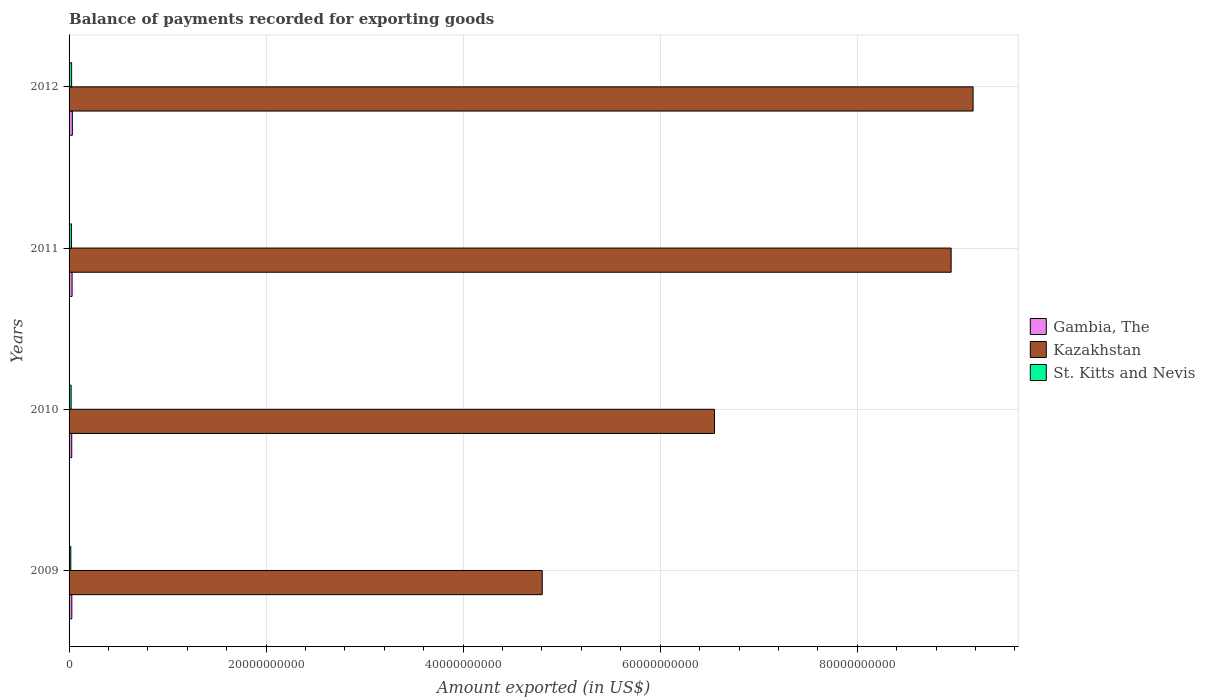How many groups of bars are there?
Offer a very short reply. 4. Are the number of bars on each tick of the Y-axis equal?
Your answer should be compact. Yes. What is the label of the 3rd group of bars from the top?
Ensure brevity in your answer.  2010. What is the amount exported in Gambia, The in 2012?
Your answer should be compact. 3.34e+08. Across all years, what is the maximum amount exported in St. Kitts and Nevis?
Your answer should be very brief. 2.57e+08. Across all years, what is the minimum amount exported in Kazakhstan?
Your answer should be compact. 4.80e+1. In which year was the amount exported in Gambia, The maximum?
Make the answer very short. 2012. What is the total amount exported in Gambia, The in the graph?
Provide a succinct answer. 1.19e+09. What is the difference between the amount exported in Gambia, The in 2011 and that in 2012?
Offer a very short reply. -2.81e+07. What is the difference between the amount exported in Gambia, The in 2009 and the amount exported in Kazakhstan in 2011?
Give a very brief answer. -8.93e+1. What is the average amount exported in Kazakhstan per year?
Keep it short and to the point. 7.37e+1. In the year 2009, what is the difference between the amount exported in Kazakhstan and amount exported in Gambia, The?
Offer a terse response. 4.77e+1. What is the ratio of the amount exported in Gambia, The in 2010 to that in 2011?
Your answer should be compact. 0.88. Is the amount exported in Kazakhstan in 2011 less than that in 2012?
Ensure brevity in your answer.  Yes. What is the difference between the highest and the second highest amount exported in St. Kitts and Nevis?
Offer a very short reply. 1.47e+07. What is the difference between the highest and the lowest amount exported in St. Kitts and Nevis?
Keep it short and to the point. 8.25e+07. In how many years, is the amount exported in St. Kitts and Nevis greater than the average amount exported in St. Kitts and Nevis taken over all years?
Offer a terse response. 2. What does the 1st bar from the top in 2009 represents?
Make the answer very short. St. Kitts and Nevis. What does the 2nd bar from the bottom in 2011 represents?
Offer a very short reply. Kazakhstan. Is it the case that in every year, the sum of the amount exported in Gambia, The and amount exported in Kazakhstan is greater than the amount exported in St. Kitts and Nevis?
Provide a short and direct response. Yes. What is the difference between two consecutive major ticks on the X-axis?
Your response must be concise. 2.00e+1. Does the graph contain any zero values?
Keep it short and to the point. No. Does the graph contain grids?
Your response must be concise. Yes. How are the legend labels stacked?
Your answer should be very brief. Vertical. What is the title of the graph?
Your response must be concise. Balance of payments recorded for exporting goods. What is the label or title of the X-axis?
Your answer should be compact. Amount exported (in US$). What is the label or title of the Y-axis?
Offer a terse response. Years. What is the Amount exported (in US$) in Gambia, The in 2009?
Your answer should be compact. 2.78e+08. What is the Amount exported (in US$) in Kazakhstan in 2009?
Offer a terse response. 4.80e+1. What is the Amount exported (in US$) of St. Kitts and Nevis in 2009?
Offer a terse response. 1.75e+08. What is the Amount exported (in US$) in Gambia, The in 2010?
Make the answer very short. 2.71e+08. What is the Amount exported (in US$) of Kazakhstan in 2010?
Offer a very short reply. 6.55e+1. What is the Amount exported (in US$) in St. Kitts and Nevis in 2010?
Provide a short and direct response. 2.08e+08. What is the Amount exported (in US$) in Gambia, The in 2011?
Offer a terse response. 3.06e+08. What is the Amount exported (in US$) in Kazakhstan in 2011?
Your response must be concise. 8.95e+1. What is the Amount exported (in US$) of St. Kitts and Nevis in 2011?
Provide a short and direct response. 2.43e+08. What is the Amount exported (in US$) in Gambia, The in 2012?
Keep it short and to the point. 3.34e+08. What is the Amount exported (in US$) of Kazakhstan in 2012?
Ensure brevity in your answer.  9.18e+1. What is the Amount exported (in US$) of St. Kitts and Nevis in 2012?
Ensure brevity in your answer.  2.57e+08. Across all years, what is the maximum Amount exported (in US$) in Gambia, The?
Offer a very short reply. 3.34e+08. Across all years, what is the maximum Amount exported (in US$) of Kazakhstan?
Ensure brevity in your answer.  9.18e+1. Across all years, what is the maximum Amount exported (in US$) in St. Kitts and Nevis?
Make the answer very short. 2.57e+08. Across all years, what is the minimum Amount exported (in US$) in Gambia, The?
Offer a very short reply. 2.71e+08. Across all years, what is the minimum Amount exported (in US$) in Kazakhstan?
Ensure brevity in your answer.  4.80e+1. Across all years, what is the minimum Amount exported (in US$) in St. Kitts and Nevis?
Offer a very short reply. 1.75e+08. What is the total Amount exported (in US$) in Gambia, The in the graph?
Provide a short and direct response. 1.19e+09. What is the total Amount exported (in US$) of Kazakhstan in the graph?
Provide a succinct answer. 2.95e+11. What is the total Amount exported (in US$) of St. Kitts and Nevis in the graph?
Provide a succinct answer. 8.83e+08. What is the difference between the Amount exported (in US$) of Gambia, The in 2009 and that in 2010?
Keep it short and to the point. 7.83e+06. What is the difference between the Amount exported (in US$) in Kazakhstan in 2009 and that in 2010?
Provide a succinct answer. -1.75e+1. What is the difference between the Amount exported (in US$) in St. Kitts and Nevis in 2009 and that in 2010?
Provide a succinct answer. -3.34e+07. What is the difference between the Amount exported (in US$) of Gambia, The in 2009 and that in 2011?
Keep it short and to the point. -2.75e+07. What is the difference between the Amount exported (in US$) in Kazakhstan in 2009 and that in 2011?
Give a very brief answer. -4.15e+1. What is the difference between the Amount exported (in US$) in St. Kitts and Nevis in 2009 and that in 2011?
Your response must be concise. -6.78e+07. What is the difference between the Amount exported (in US$) of Gambia, The in 2009 and that in 2012?
Offer a very short reply. -5.55e+07. What is the difference between the Amount exported (in US$) of Kazakhstan in 2009 and that in 2012?
Provide a short and direct response. -4.37e+1. What is the difference between the Amount exported (in US$) of St. Kitts and Nevis in 2009 and that in 2012?
Your answer should be very brief. -8.25e+07. What is the difference between the Amount exported (in US$) of Gambia, The in 2010 and that in 2011?
Offer a terse response. -3.53e+07. What is the difference between the Amount exported (in US$) of Kazakhstan in 2010 and that in 2011?
Your response must be concise. -2.40e+1. What is the difference between the Amount exported (in US$) in St. Kitts and Nevis in 2010 and that in 2011?
Ensure brevity in your answer.  -3.44e+07. What is the difference between the Amount exported (in US$) of Gambia, The in 2010 and that in 2012?
Provide a succinct answer. -6.34e+07. What is the difference between the Amount exported (in US$) in Kazakhstan in 2010 and that in 2012?
Give a very brief answer. -2.62e+1. What is the difference between the Amount exported (in US$) of St. Kitts and Nevis in 2010 and that in 2012?
Offer a terse response. -4.91e+07. What is the difference between the Amount exported (in US$) of Gambia, The in 2011 and that in 2012?
Keep it short and to the point. -2.81e+07. What is the difference between the Amount exported (in US$) of Kazakhstan in 2011 and that in 2012?
Provide a succinct answer. -2.23e+09. What is the difference between the Amount exported (in US$) of St. Kitts and Nevis in 2011 and that in 2012?
Keep it short and to the point. -1.47e+07. What is the difference between the Amount exported (in US$) in Gambia, The in 2009 and the Amount exported (in US$) in Kazakhstan in 2010?
Provide a succinct answer. -6.52e+1. What is the difference between the Amount exported (in US$) of Gambia, The in 2009 and the Amount exported (in US$) of St. Kitts and Nevis in 2010?
Provide a short and direct response. 7.03e+07. What is the difference between the Amount exported (in US$) in Kazakhstan in 2009 and the Amount exported (in US$) in St. Kitts and Nevis in 2010?
Provide a succinct answer. 4.78e+1. What is the difference between the Amount exported (in US$) in Gambia, The in 2009 and the Amount exported (in US$) in Kazakhstan in 2011?
Offer a terse response. -8.93e+1. What is the difference between the Amount exported (in US$) of Gambia, The in 2009 and the Amount exported (in US$) of St. Kitts and Nevis in 2011?
Provide a short and direct response. 3.58e+07. What is the difference between the Amount exported (in US$) of Kazakhstan in 2009 and the Amount exported (in US$) of St. Kitts and Nevis in 2011?
Offer a very short reply. 4.78e+1. What is the difference between the Amount exported (in US$) in Gambia, The in 2009 and the Amount exported (in US$) in Kazakhstan in 2012?
Provide a succinct answer. -9.15e+1. What is the difference between the Amount exported (in US$) of Gambia, The in 2009 and the Amount exported (in US$) of St. Kitts and Nevis in 2012?
Offer a very short reply. 2.12e+07. What is the difference between the Amount exported (in US$) in Kazakhstan in 2009 and the Amount exported (in US$) in St. Kitts and Nevis in 2012?
Ensure brevity in your answer.  4.78e+1. What is the difference between the Amount exported (in US$) in Gambia, The in 2010 and the Amount exported (in US$) in Kazakhstan in 2011?
Provide a succinct answer. -8.93e+1. What is the difference between the Amount exported (in US$) of Gambia, The in 2010 and the Amount exported (in US$) of St. Kitts and Nevis in 2011?
Your answer should be very brief. 2.80e+07. What is the difference between the Amount exported (in US$) of Kazakhstan in 2010 and the Amount exported (in US$) of St. Kitts and Nevis in 2011?
Make the answer very short. 6.53e+1. What is the difference between the Amount exported (in US$) in Gambia, The in 2010 and the Amount exported (in US$) in Kazakhstan in 2012?
Your answer should be very brief. -9.15e+1. What is the difference between the Amount exported (in US$) of Gambia, The in 2010 and the Amount exported (in US$) of St. Kitts and Nevis in 2012?
Make the answer very short. 1.33e+07. What is the difference between the Amount exported (in US$) of Kazakhstan in 2010 and the Amount exported (in US$) of St. Kitts and Nevis in 2012?
Ensure brevity in your answer.  6.53e+1. What is the difference between the Amount exported (in US$) in Gambia, The in 2011 and the Amount exported (in US$) in Kazakhstan in 2012?
Offer a very short reply. -9.15e+1. What is the difference between the Amount exported (in US$) of Gambia, The in 2011 and the Amount exported (in US$) of St. Kitts and Nevis in 2012?
Offer a terse response. 4.86e+07. What is the difference between the Amount exported (in US$) in Kazakhstan in 2011 and the Amount exported (in US$) in St. Kitts and Nevis in 2012?
Provide a short and direct response. 8.93e+1. What is the average Amount exported (in US$) of Gambia, The per year?
Provide a succinct answer. 2.97e+08. What is the average Amount exported (in US$) of Kazakhstan per year?
Make the answer very short. 7.37e+1. What is the average Amount exported (in US$) of St. Kitts and Nevis per year?
Provide a short and direct response. 2.21e+08. In the year 2009, what is the difference between the Amount exported (in US$) in Gambia, The and Amount exported (in US$) in Kazakhstan?
Offer a very short reply. -4.77e+1. In the year 2009, what is the difference between the Amount exported (in US$) of Gambia, The and Amount exported (in US$) of St. Kitts and Nevis?
Your response must be concise. 1.04e+08. In the year 2009, what is the difference between the Amount exported (in US$) in Kazakhstan and Amount exported (in US$) in St. Kitts and Nevis?
Provide a short and direct response. 4.79e+1. In the year 2010, what is the difference between the Amount exported (in US$) in Gambia, The and Amount exported (in US$) in Kazakhstan?
Your answer should be compact. -6.52e+1. In the year 2010, what is the difference between the Amount exported (in US$) in Gambia, The and Amount exported (in US$) in St. Kitts and Nevis?
Make the answer very short. 6.24e+07. In the year 2010, what is the difference between the Amount exported (in US$) in Kazakhstan and Amount exported (in US$) in St. Kitts and Nevis?
Give a very brief answer. 6.53e+1. In the year 2011, what is the difference between the Amount exported (in US$) in Gambia, The and Amount exported (in US$) in Kazakhstan?
Ensure brevity in your answer.  -8.92e+1. In the year 2011, what is the difference between the Amount exported (in US$) of Gambia, The and Amount exported (in US$) of St. Kitts and Nevis?
Provide a succinct answer. 6.33e+07. In the year 2011, what is the difference between the Amount exported (in US$) of Kazakhstan and Amount exported (in US$) of St. Kitts and Nevis?
Give a very brief answer. 8.93e+1. In the year 2012, what is the difference between the Amount exported (in US$) in Gambia, The and Amount exported (in US$) in Kazakhstan?
Ensure brevity in your answer.  -9.14e+1. In the year 2012, what is the difference between the Amount exported (in US$) of Gambia, The and Amount exported (in US$) of St. Kitts and Nevis?
Provide a succinct answer. 7.67e+07. In the year 2012, what is the difference between the Amount exported (in US$) of Kazakhstan and Amount exported (in US$) of St. Kitts and Nevis?
Provide a succinct answer. 9.15e+1. What is the ratio of the Amount exported (in US$) in Gambia, The in 2009 to that in 2010?
Offer a very short reply. 1.03. What is the ratio of the Amount exported (in US$) in Kazakhstan in 2009 to that in 2010?
Your answer should be compact. 0.73. What is the ratio of the Amount exported (in US$) in St. Kitts and Nevis in 2009 to that in 2010?
Give a very brief answer. 0.84. What is the ratio of the Amount exported (in US$) of Gambia, The in 2009 to that in 2011?
Your answer should be very brief. 0.91. What is the ratio of the Amount exported (in US$) in Kazakhstan in 2009 to that in 2011?
Make the answer very short. 0.54. What is the ratio of the Amount exported (in US$) of St. Kitts and Nevis in 2009 to that in 2011?
Offer a very short reply. 0.72. What is the ratio of the Amount exported (in US$) of Gambia, The in 2009 to that in 2012?
Give a very brief answer. 0.83. What is the ratio of the Amount exported (in US$) of Kazakhstan in 2009 to that in 2012?
Your answer should be compact. 0.52. What is the ratio of the Amount exported (in US$) in St. Kitts and Nevis in 2009 to that in 2012?
Your answer should be very brief. 0.68. What is the ratio of the Amount exported (in US$) in Gambia, The in 2010 to that in 2011?
Your answer should be compact. 0.88. What is the ratio of the Amount exported (in US$) of Kazakhstan in 2010 to that in 2011?
Ensure brevity in your answer.  0.73. What is the ratio of the Amount exported (in US$) in St. Kitts and Nevis in 2010 to that in 2011?
Your answer should be very brief. 0.86. What is the ratio of the Amount exported (in US$) in Gambia, The in 2010 to that in 2012?
Your answer should be very brief. 0.81. What is the ratio of the Amount exported (in US$) in Kazakhstan in 2010 to that in 2012?
Offer a very short reply. 0.71. What is the ratio of the Amount exported (in US$) of St. Kitts and Nevis in 2010 to that in 2012?
Offer a terse response. 0.81. What is the ratio of the Amount exported (in US$) in Gambia, The in 2011 to that in 2012?
Your response must be concise. 0.92. What is the ratio of the Amount exported (in US$) in Kazakhstan in 2011 to that in 2012?
Your response must be concise. 0.98. What is the ratio of the Amount exported (in US$) in St. Kitts and Nevis in 2011 to that in 2012?
Make the answer very short. 0.94. What is the difference between the highest and the second highest Amount exported (in US$) in Gambia, The?
Ensure brevity in your answer.  2.81e+07. What is the difference between the highest and the second highest Amount exported (in US$) in Kazakhstan?
Provide a succinct answer. 2.23e+09. What is the difference between the highest and the second highest Amount exported (in US$) of St. Kitts and Nevis?
Give a very brief answer. 1.47e+07. What is the difference between the highest and the lowest Amount exported (in US$) of Gambia, The?
Ensure brevity in your answer.  6.34e+07. What is the difference between the highest and the lowest Amount exported (in US$) of Kazakhstan?
Provide a short and direct response. 4.37e+1. What is the difference between the highest and the lowest Amount exported (in US$) in St. Kitts and Nevis?
Ensure brevity in your answer.  8.25e+07. 